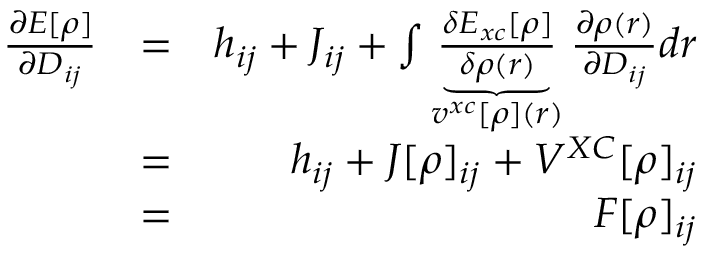<formula> <loc_0><loc_0><loc_500><loc_500>\begin{array} { r l r } { \frac { \partial E [ \rho ] } { \partial D _ { i j } } } & { = } & { h _ { i j } + J _ { i j } + \int \underbrace { \frac { \delta E _ { x c } [ \rho ] } { \delta \rho ( r ) } } _ { v ^ { x c } [ \rho ] ( r ) } \frac { \partial \rho ( r ) } { \partial D _ { i j } } d r } \\ & { = } & { h _ { i j } + J [ \rho ] _ { i j } + V ^ { X C } [ \rho ] _ { i j } } \\ & { = } & { F [ \rho ] _ { i j } } \end{array}</formula> 